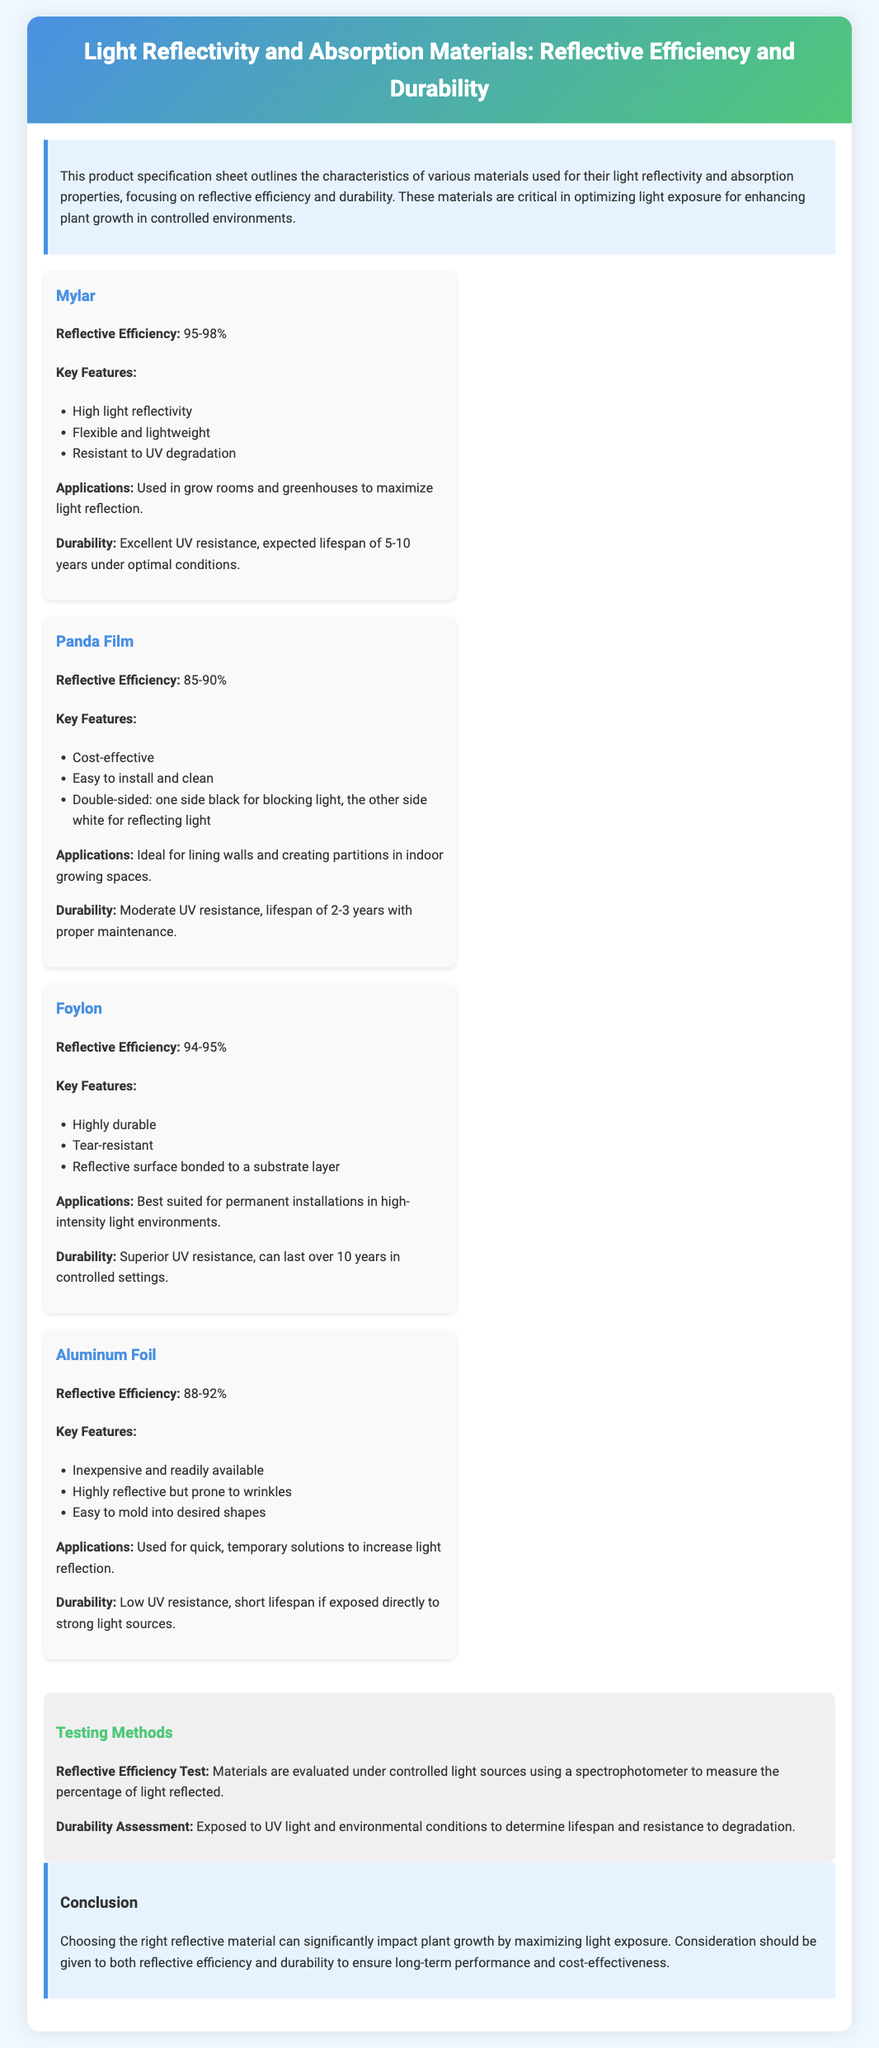What is the reflective efficiency range of Mylar? Mylar's reflective efficiency is stated in the document as ranging from 95-98%.
Answer: 95-98% What is the expected lifespan of Panda Film under optimal conditions? The document mentions that Panda Film has an expected lifespan of 2-3 years with proper maintenance.
Answer: 2-3 years Which material is described as highly durable? The document specifically describes Foylon as being highly durable among the listed materials.
Answer: Foylon What is the reflective efficiency of Aluminum Foil? Aluminum Foil's reflective efficiency is noted in the document as being between 88-92%.
Answer: 88-92% Which material has excellent UV resistance and a lifespan of over 10 years? The document highlights Foylon as having superior UV resistance and an expected lifespan of over 10 years.
Answer: Foylon How are materials tested for reflective efficiency? The testing method described in the document states that materials are evaluated under controlled light sources using a spectrophotometer.
Answer: Spectrophotometer What is a key feature of Panda Film? The document lists that a key feature of Panda Film is that it is double-sided, one side black and the other side white.
Answer: Double-sided What is the durability of Mylar? The document states that Mylar has an excellent UV resistance with an expected lifespan of 5-10 years under optimal conditions.
Answer: 5-10 years 